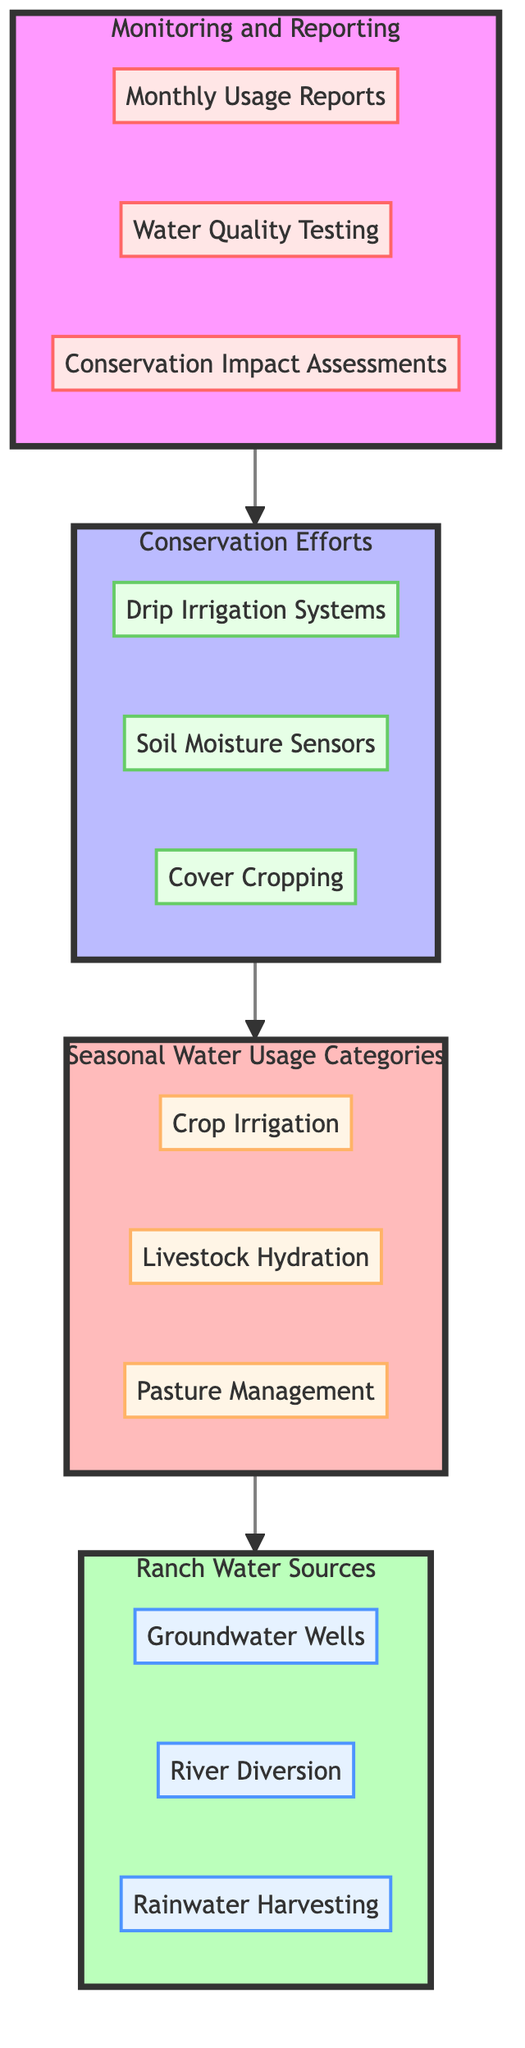What are the three sources of ranch water? The diagram lists three specific sources of ranch water: Groundwater Wells, River Diversion, and Rainwater Harvesting. These are categorized under the "Ranch Water Sources" section.
Answer: Groundwater Wells, River Diversion, Rainwater Harvesting How many seasonal water usage categories are listed? The diagram presents three distinct categories under "Seasonal Water Usage Categories": Crop Irrigation, Livestock Hydration, and Pasture Management. Thus, the number of categories is three.
Answer: 3 What is the first step in the flow of the diagram? The flowchart begins with "Monitoring and Reporting" as the first step, leading to the next section, which is "Conservation Efforts." This clarifies the initial action taken in the water usage process.
Answer: Monitoring and Reporting Which conservation method directly follows the monitoring process? "Conservation Efforts" come right after "Monitoring and Reporting," and within it, Drip Irrigation Systems is the first listed conservation method, indicating its immediate relevance following monitoring.
Answer: Drip Irrigation Systems What is the type of the elements under the "Conservation Efforts"? All sub-elements under "Conservation Efforts" are categorized as methods. This includes Drip Irrigation Systems, Soil Moisture Sensors, and Cover Cropping, thus establishing their function in conservation practices.
Answer: Method How does "Monitoring and Reporting" relate to "Conservation Efforts"? "Monitoring and Reporting" directly leads into "Conservation Efforts," indicating that monitoring data inspires or informs the adoption of conservation methods. This shows a cause-and-effect relationship within the flow.
Answer: Leads to Which water usage category is focused on animal needs? The "Livestock Hydration" category under "Seasonal Water Usage Categories" directly addresses the water requirements specifically for the animals on the ranch. This identifies its role in meeting livestock needs.
Answer: Livestock Hydration What tool is listed for assessing conservation impact? "Conservation Impact Assessments" is identified as a specific tool under "Monitoring and Reporting," suggesting its importance in evaluating how effective the conservation strategies have been.
Answer: Conservation Impact Assessments How many methods are proposed for water conservation? The diagram outlines three methods under "Conservation Efforts": Drip Irrigation Systems, Soil Moisture Sensors, and Cover Cropping, thus indicating a total of three proposed methods for conservation.
Answer: 3 